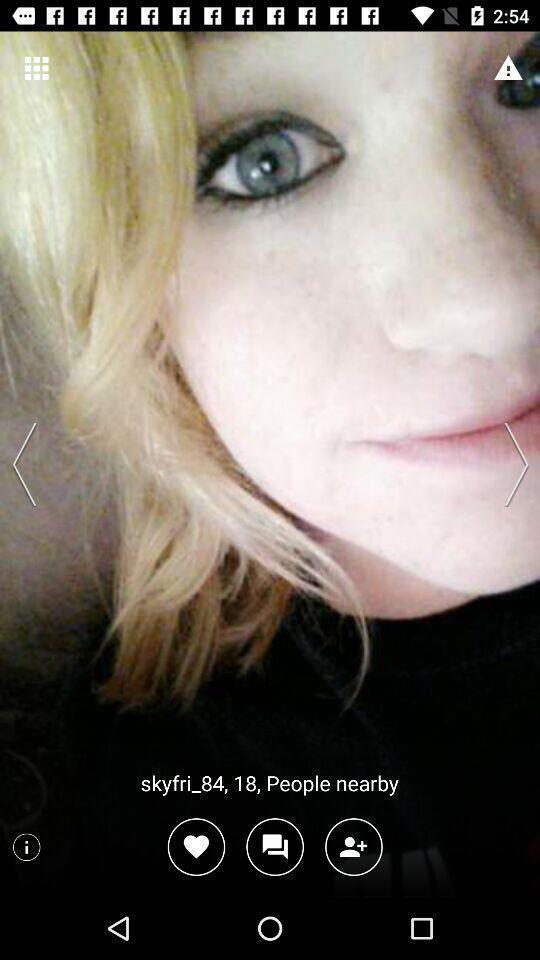Describe the content in this image. Page displaying a picture with few options in dating app. 